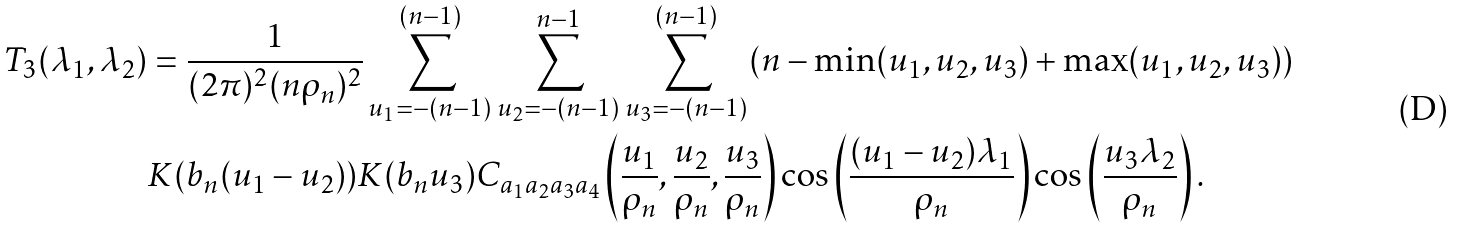Convert formula to latex. <formula><loc_0><loc_0><loc_500><loc_500>T _ { 3 } ( \lambda _ { 1 } , \lambda _ { 2 } ) & = \frac { 1 } { ( 2 \pi ) ^ { 2 } ( n \rho _ { n } ) ^ { 2 } } \sum _ { u _ { 1 } = - ( n - 1 ) } ^ { ( n - 1 ) } \sum _ { u _ { 2 } = - ( n - 1 ) } ^ { n - 1 } \sum _ { u _ { 3 } = - ( n - 1 ) } ^ { ( n - 1 ) } ( n - \min ( u _ { 1 } , u _ { 2 } , u _ { 3 } ) + \max ( u _ { 1 } , u _ { 2 } , u _ { 3 } ) ) \\ & K ( b _ { n } ( u _ { 1 } - u _ { 2 } ) ) K ( b _ { n } u _ { 3 } ) C _ { a _ { 1 } a _ { 2 } a _ { 3 } a _ { 4 } } \left ( \frac { u _ { 1 } } { \rho _ { n } } , \frac { u _ { 2 } } { \rho _ { n } } , \frac { u _ { 3 } } { \rho _ { n } } \right ) \cos \left ( \frac { ( u _ { 1 } - u _ { 2 } ) \lambda _ { 1 } } { \rho _ { n } } \right ) \cos \left ( \frac { u _ { 3 } \lambda _ { 2 } } { \rho _ { n } } \right ) .</formula> 